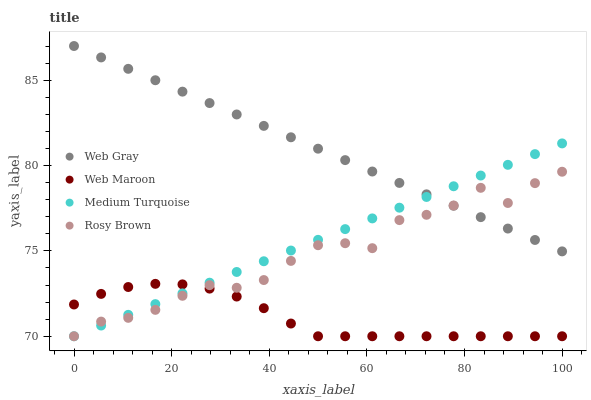Does Web Maroon have the minimum area under the curve?
Answer yes or no. Yes. Does Web Gray have the maximum area under the curve?
Answer yes or no. Yes. Does Web Gray have the minimum area under the curve?
Answer yes or no. No. Does Web Maroon have the maximum area under the curve?
Answer yes or no. No. Is Medium Turquoise the smoothest?
Answer yes or no. Yes. Is Rosy Brown the roughest?
Answer yes or no. Yes. Is Web Gray the smoothest?
Answer yes or no. No. Is Web Gray the roughest?
Answer yes or no. No. Does Rosy Brown have the lowest value?
Answer yes or no. Yes. Does Web Gray have the lowest value?
Answer yes or no. No. Does Web Gray have the highest value?
Answer yes or no. Yes. Does Web Maroon have the highest value?
Answer yes or no. No. Is Web Maroon less than Web Gray?
Answer yes or no. Yes. Is Web Gray greater than Web Maroon?
Answer yes or no. Yes. Does Web Maroon intersect Medium Turquoise?
Answer yes or no. Yes. Is Web Maroon less than Medium Turquoise?
Answer yes or no. No. Is Web Maroon greater than Medium Turquoise?
Answer yes or no. No. Does Web Maroon intersect Web Gray?
Answer yes or no. No. 